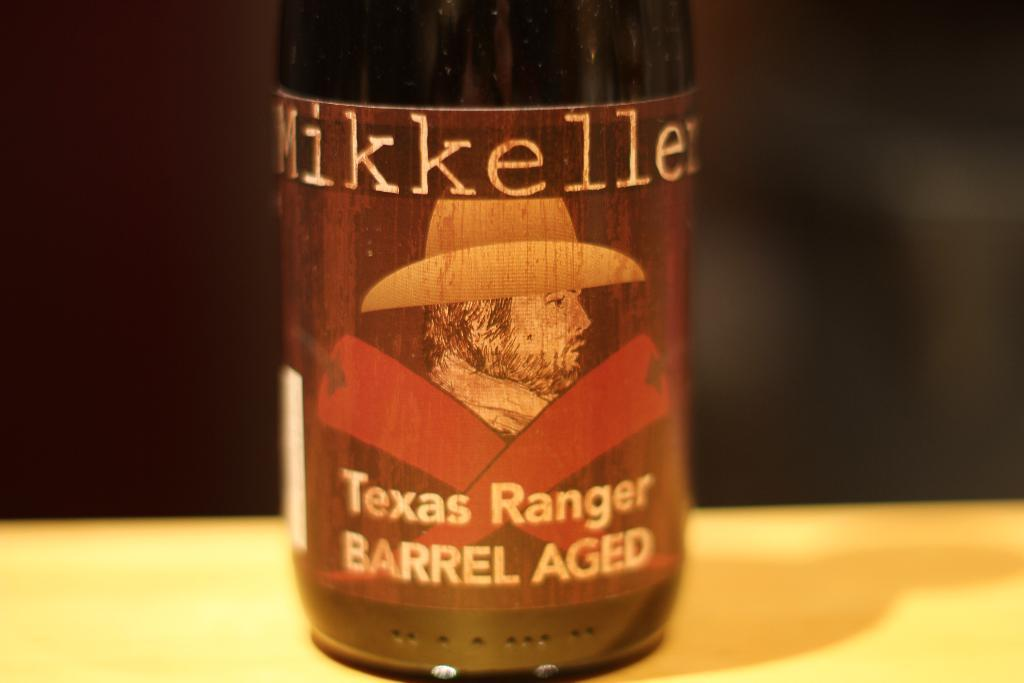<image>
Give a short and clear explanation of the subsequent image. A bottle of Mikkeller Texas Ranger Barrel Aged alcohol. 